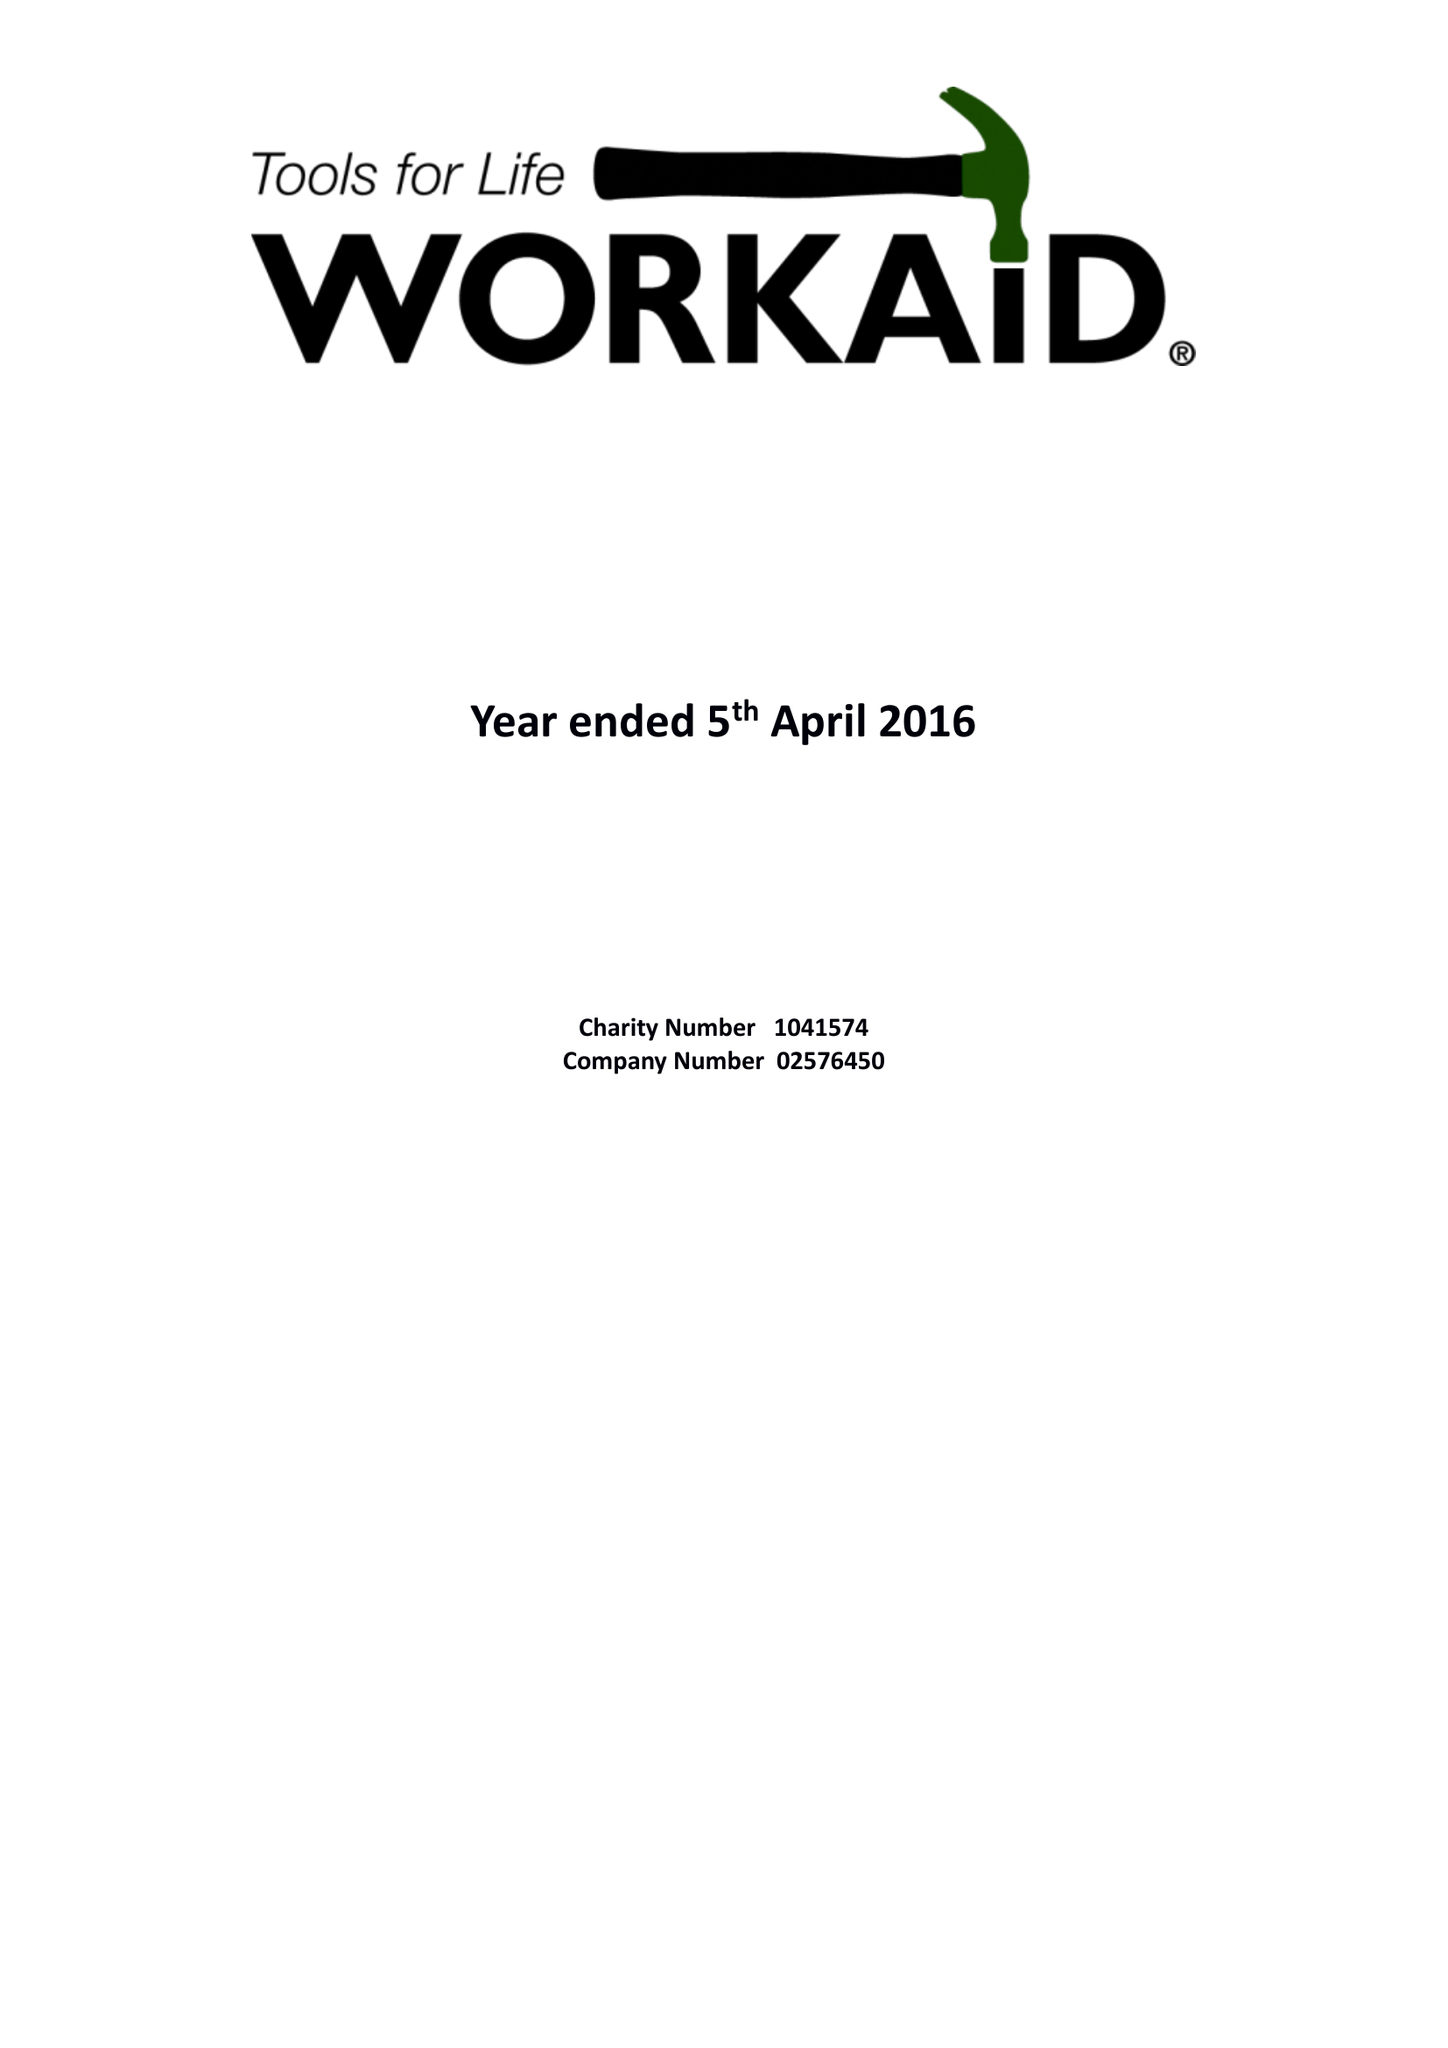What is the value for the charity_name?
Answer the question using a single word or phrase. Workaid 